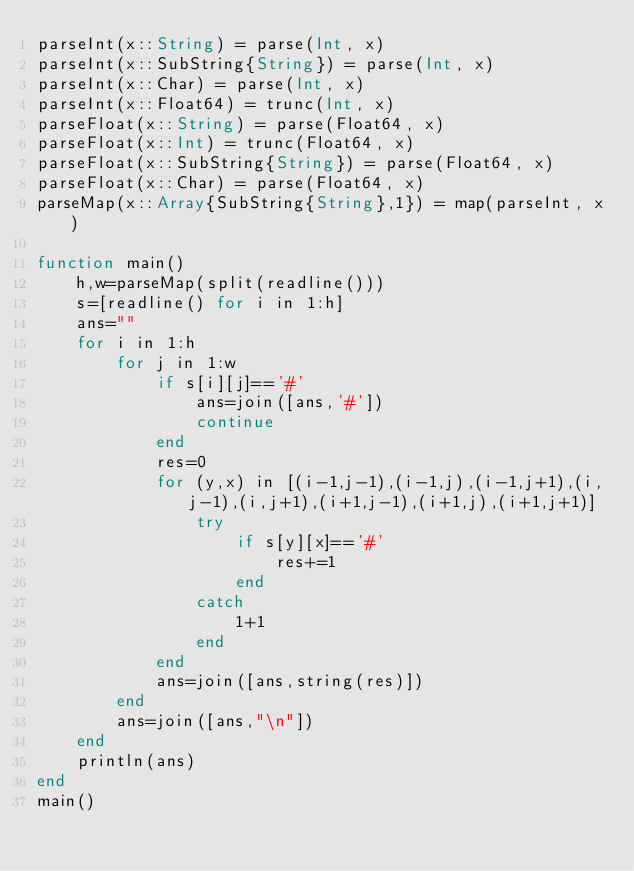<code> <loc_0><loc_0><loc_500><loc_500><_Julia_>parseInt(x::String) = parse(Int, x)
parseInt(x::SubString{String}) = parse(Int, x)
parseInt(x::Char) = parse(Int, x)
parseInt(x::Float64) = trunc(Int, x)
parseFloat(x::String) = parse(Float64, x)
parseFloat(x::Int) = trunc(Float64, x)
parseFloat(x::SubString{String}) = parse(Float64, x)
parseFloat(x::Char) = parse(Float64, x)
parseMap(x::Array{SubString{String},1}) = map(parseInt, x)

function main()
    h,w=parseMap(split(readline()))
    s=[readline() for i in 1:h]
    ans=""
    for i in 1:h
        for j in 1:w
            if s[i][j]=='#'
                ans=join([ans,'#'])
                continue
            end
            res=0
            for (y,x) in [(i-1,j-1),(i-1,j),(i-1,j+1),(i,j-1),(i,j+1),(i+1,j-1),(i+1,j),(i+1,j+1)]
                try
                    if s[y][x]=='#'
                        res+=1
                    end
                catch
                    1+1
                end
            end
            ans=join([ans,string(res)])
        end
        ans=join([ans,"\n"])
    end
    println(ans)
end
main()</code> 